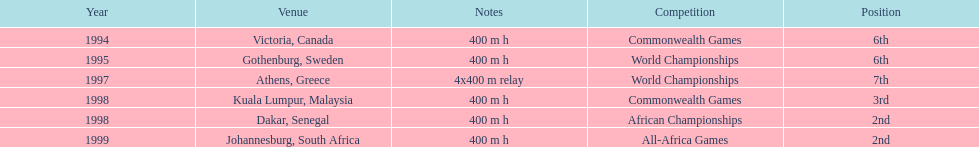What is the number of titles ken harden has one 6. 